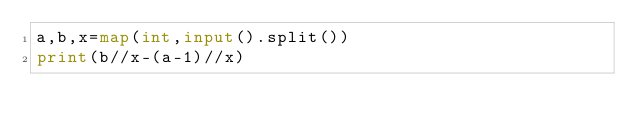Convert code to text. <code><loc_0><loc_0><loc_500><loc_500><_Python_>a,b,x=map(int,input().split())
print(b//x-(a-1)//x)</code> 